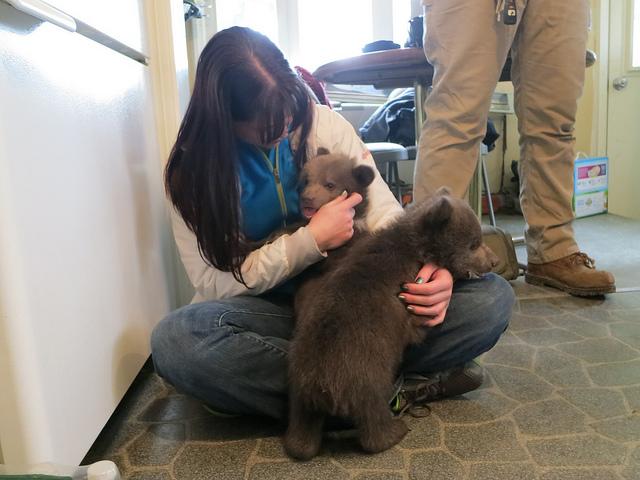What kind of cubs are these?
Write a very short answer. Bear. What is the female human doing with the animals?
Keep it brief. Playing. What is the relation between these cubs?
Quick response, please. Siblings. 